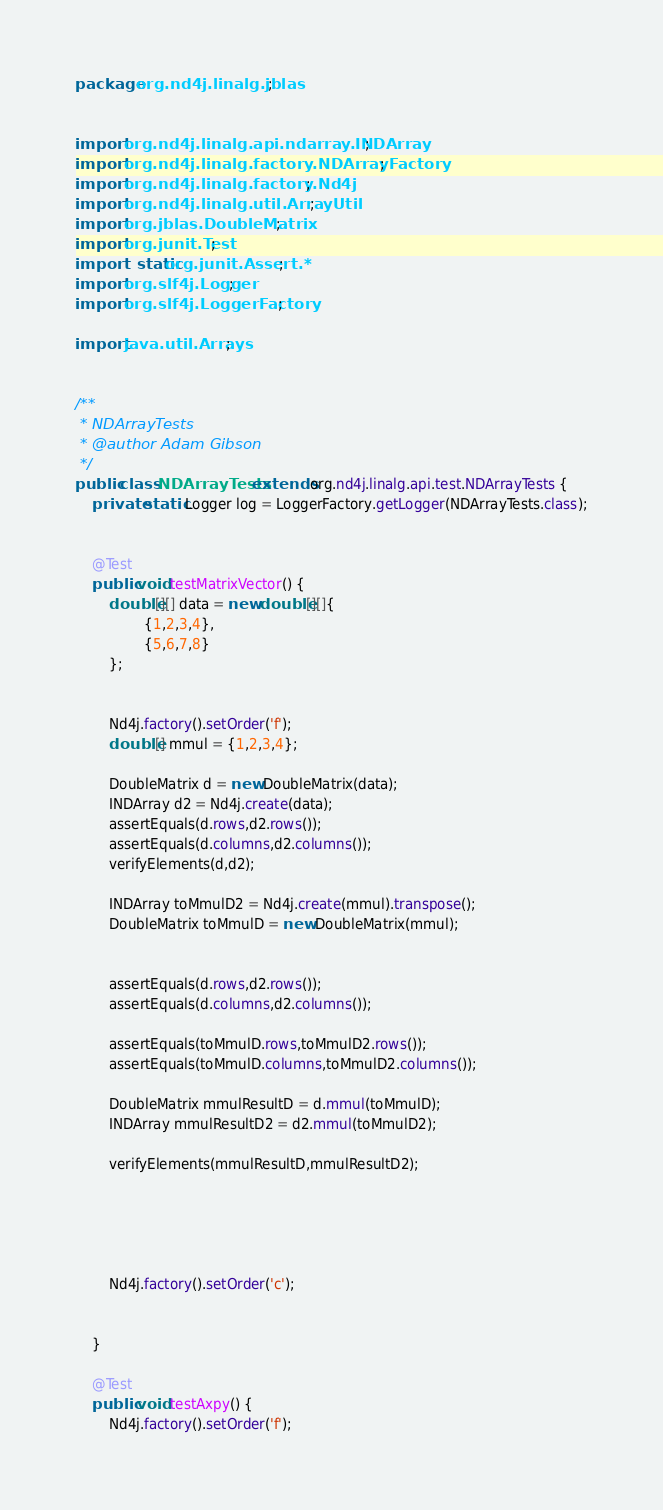Convert code to text. <code><loc_0><loc_0><loc_500><loc_500><_Java_>package org.nd4j.linalg.jblas;


import org.nd4j.linalg.api.ndarray.INDArray;
import org.nd4j.linalg.factory.NDArrayFactory;
import org.nd4j.linalg.factory.Nd4j;
import org.nd4j.linalg.util.ArrayUtil;
import org.jblas.DoubleMatrix;
import org.junit.Test;
import static org.junit.Assert.*;
import org.slf4j.Logger;
import org.slf4j.LoggerFactory;

import java.util.Arrays;


/**
 * NDArrayTests
 * @author Adam Gibson
 */
public class NDArrayTests extends org.nd4j.linalg.api.test.NDArrayTests {
    private static Logger log = LoggerFactory.getLogger(NDArrayTests.class);


    @Test
    public void testMatrixVector() {
        double[][] data = new double[][]{
                {1,2,3,4},
                {5,6,7,8}
        };


        Nd4j.factory().setOrder('f');
        double[] mmul = {1,2,3,4};

        DoubleMatrix d = new DoubleMatrix(data);
        INDArray d2 = Nd4j.create(data);
        assertEquals(d.rows,d2.rows());
        assertEquals(d.columns,d2.columns());
        verifyElements(d,d2);

        INDArray toMmulD2 = Nd4j.create(mmul).transpose();
        DoubleMatrix toMmulD = new DoubleMatrix(mmul);


        assertEquals(d.rows,d2.rows());
        assertEquals(d.columns,d2.columns());

        assertEquals(toMmulD.rows,toMmulD2.rows());
        assertEquals(toMmulD.columns,toMmulD2.columns());

        DoubleMatrix mmulResultD = d.mmul(toMmulD);
        INDArray mmulResultD2 = d2.mmul(toMmulD2);

        verifyElements(mmulResultD,mmulResultD2);





        Nd4j.factory().setOrder('c');


    }

    @Test
    public void testAxpy() {
        Nd4j.factory().setOrder('f');
</code> 